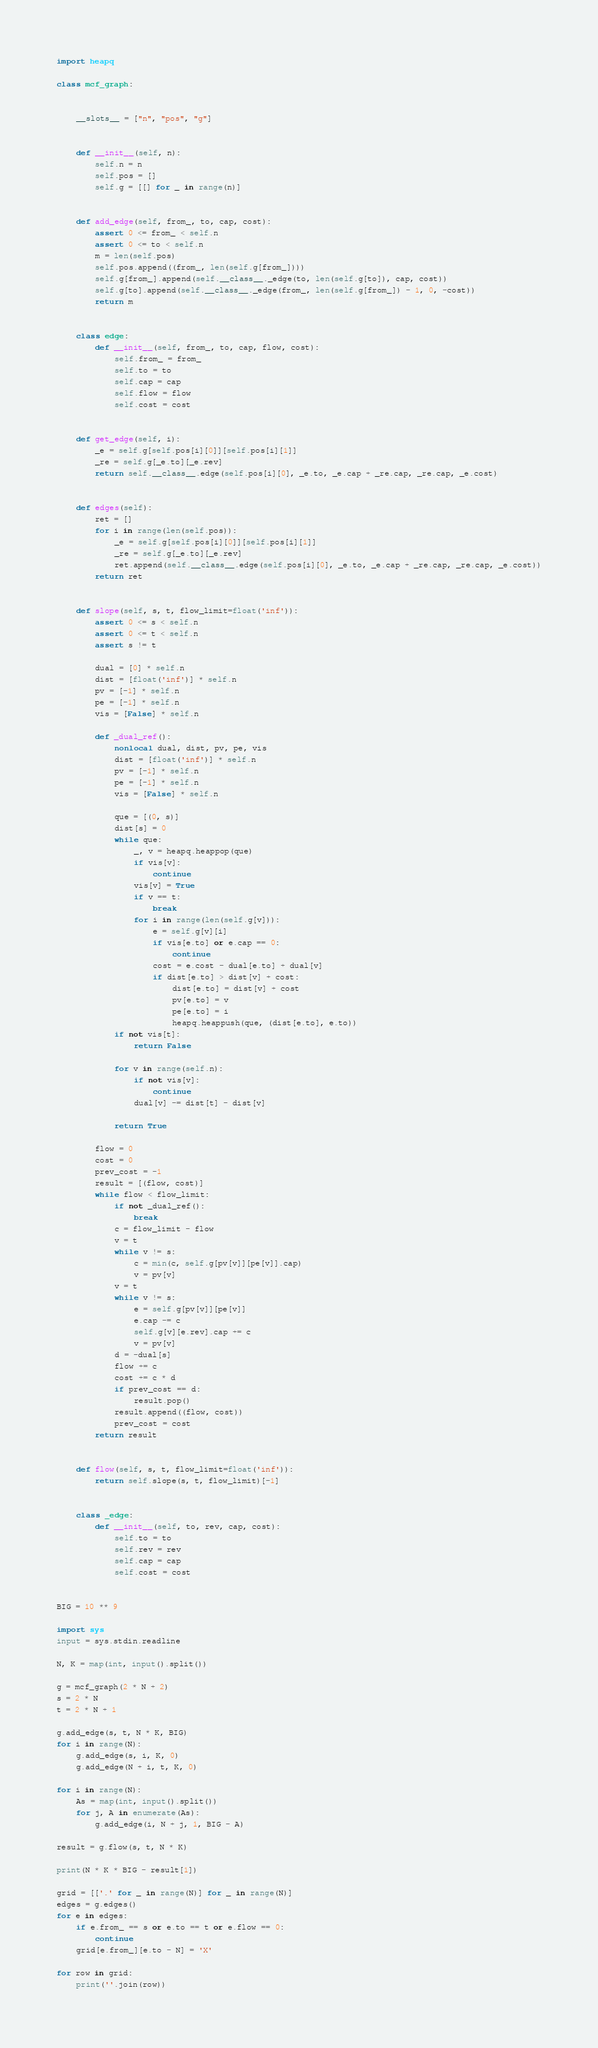<code> <loc_0><loc_0><loc_500><loc_500><_Python_>import heapq

class mcf_graph:

    
    __slots__ = ["n", "pos", "g"]


    def __init__(self, n):
        self.n = n
        self.pos = []
        self.g = [[] for _ in range(n)]


    def add_edge(self, from_, to, cap, cost):
        assert 0 <= from_ < self.n
        assert 0 <= to < self.n
        m = len(self.pos)
        self.pos.append((from_, len(self.g[from_])))
        self.g[from_].append(self.__class__._edge(to, len(self.g[to]), cap, cost))
        self.g[to].append(self.__class__._edge(from_, len(self.g[from_]) - 1, 0, -cost))
        return m


    class edge:
        def __init__(self, from_, to, cap, flow, cost):
            self.from_ = from_
            self.to = to
            self.cap = cap
            self.flow = flow
            self.cost = cost


    def get_edge(self, i):
        _e = self.g[self.pos[i][0]][self.pos[i][1]]
        _re = self.g[_e.to][_e.rev]
        return self.__class__.edge(self.pos[i][0], _e.to, _e.cap + _re.cap, _re.cap, _e.cost)


    def edges(self):
        ret = []
        for i in range(len(self.pos)):
            _e = self.g[self.pos[i][0]][self.pos[i][1]]
            _re = self.g[_e.to][_e.rev]
            ret.append(self.__class__.edge(self.pos[i][0], _e.to, _e.cap + _re.cap, _re.cap, _e.cost))
        return ret


    def slope(self, s, t, flow_limit=float('inf')):
        assert 0 <= s < self.n
        assert 0 <= t < self.n
        assert s != t
        
        dual = [0] * self.n
        dist = [float('inf')] * self.n
        pv = [-1] * self.n
        pe = [-1] * self.n
        vis = [False] * self.n

        def _dual_ref():
            nonlocal dual, dist, pv, pe, vis
            dist = [float('inf')] * self.n
            pv = [-1] * self.n
            pe = [-1] * self.n
            vis = [False] * self.n

            que = [(0, s)]
            dist[s] = 0
            while que:
                _, v = heapq.heappop(que)
                if vis[v]:
                    continue
                vis[v] = True
                if v == t:
                    break
                for i in range(len(self.g[v])):
                    e = self.g[v][i]
                    if vis[e.to] or e.cap == 0:
                        continue
                    cost = e.cost - dual[e.to] + dual[v]
                    if dist[e.to] > dist[v] + cost:
                        dist[e.to] = dist[v] + cost
                        pv[e.to] = v
                        pe[e.to] = i
                        heapq.heappush(que, (dist[e.to], e.to))
            if not vis[t]:
                return False

            for v in range(self.n):
                if not vis[v]:
                    continue
                dual[v] -= dist[t] - dist[v]
            
            return True

        flow = 0
        cost = 0
        prev_cost = -1
        result = [(flow, cost)]
        while flow < flow_limit:
            if not _dual_ref():
                break
            c = flow_limit - flow
            v = t
            while v != s:
                c = min(c, self.g[pv[v]][pe[v]].cap)
                v = pv[v]
            v = t
            while v != s:
                e = self.g[pv[v]][pe[v]]
                e.cap -= c
                self.g[v][e.rev].cap += c
                v = pv[v]
            d = -dual[s]
            flow += c
            cost += c * d
            if prev_cost == d:
                result.pop()
            result.append((flow, cost))
            prev_cost = cost
        return result


    def flow(self, s, t, flow_limit=float('inf')):
        return self.slope(s, t, flow_limit)[-1]

    
    class _edge:
        def __init__(self, to, rev, cap, cost):
            self.to = to
            self.rev = rev
            self.cap = cap
            self.cost = cost


BIG = 10 ** 9

import sys
input = sys.stdin.readline

N, K = map(int, input().split())

g = mcf_graph(2 * N + 2)
s = 2 * N
t = 2 * N + 1

g.add_edge(s, t, N * K, BIG)
for i in range(N):
    g.add_edge(s, i, K, 0)
    g.add_edge(N + i, t, K, 0)

for i in range(N):
    As = map(int, input().split())
    for j, A in enumerate(As):
        g.add_edge(i, N + j, 1, BIG - A)

result = g.flow(s, t, N * K)

print(N * K * BIG - result[1])

grid = [['.' for _ in range(N)] for _ in range(N)]
edges = g.edges()
for e in edges:
    if e.from_ == s or e.to == t or e.flow == 0:
        continue
    grid[e.from_][e.to - N] = 'X'

for row in grid:
    print(''.join(row))</code> 